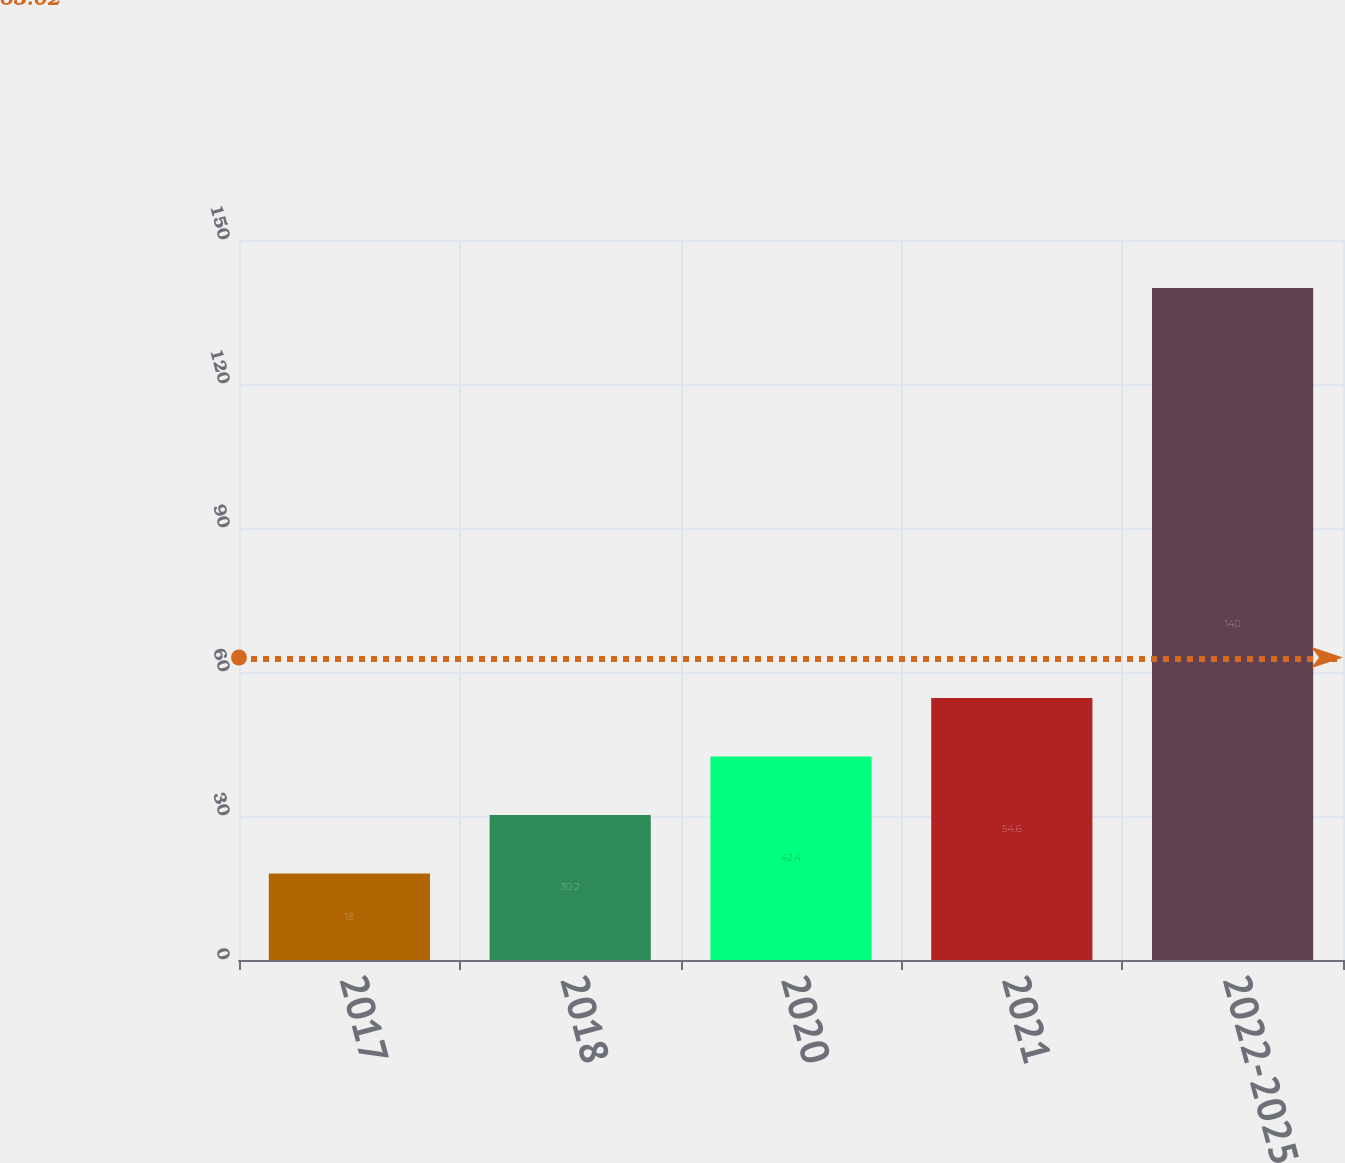<chart> <loc_0><loc_0><loc_500><loc_500><bar_chart><fcel>2017<fcel>2018<fcel>2020<fcel>2021<fcel>2022-2025<nl><fcel>18<fcel>30.2<fcel>42.4<fcel>54.6<fcel>140<nl></chart> 